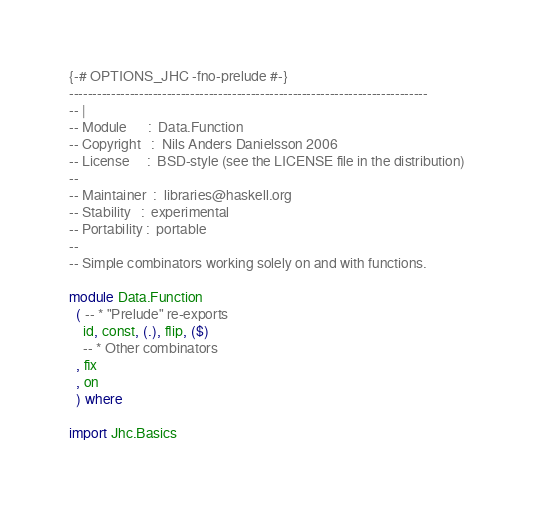<code> <loc_0><loc_0><loc_500><loc_500><_Haskell_>{-# OPTIONS_JHC -fno-prelude #-}
-----------------------------------------------------------------------------
-- |
-- Module      :  Data.Function
-- Copyright   :  Nils Anders Danielsson 2006
-- License     :  BSD-style (see the LICENSE file in the distribution)
--
-- Maintainer  :  libraries@haskell.org
-- Stability   :  experimental
-- Portability :  portable
--
-- Simple combinators working solely on and with functions.

module Data.Function
  ( -- * "Prelude" re-exports
    id, const, (.), flip, ($)
    -- * Other combinators
  , fix
  , on
  ) where

import Jhc.Basics
</code> 